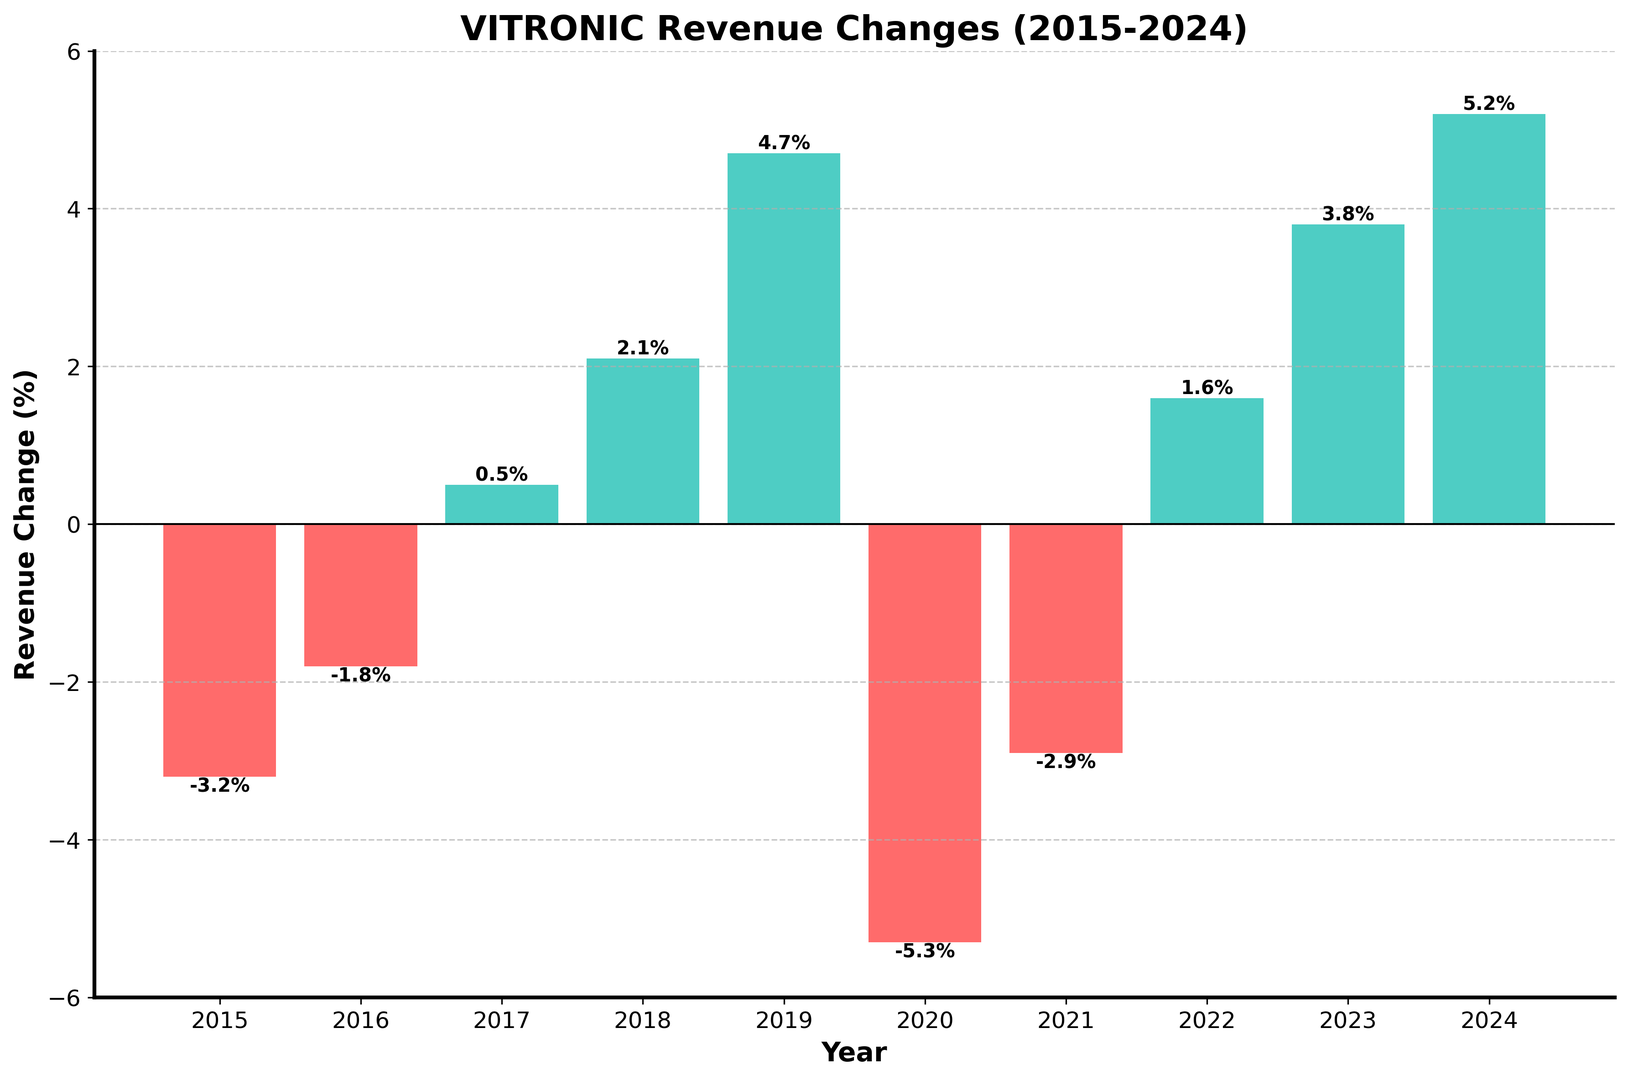How many years show a negative revenue change? By counting the number of bars that are below the zero line, we can identify how many years have negative revenue changes. The bars for the years 2015, 2016, 2020, and 2021 fall below the x-axis.
Answer: 4 Which year experienced the highest positive revenue change? By comparing the heights of the green bars above the zero line, we can identify the tallest one. The tallest green bar is in 2024.
Answer: 2024 Which year witnessed the steepest decline in revenue change? To answer this, look for the red bar that goes the farthest below the zero line. The bar for the year 2020 has the lowest value at -5.3%.
Answer: 2020 What's the average revenue change for years with positive growth? Calculate the average for the positive values: (0.5 + 2.1 + 4.7 + 1.6 + 3.8 + 5.2) / 6 = (17.9) / 6
Answer: 2.98% Between which two years does the time span contain exactly one instance of revenue decline? Against the background of counting negative and positive changes, the span from 2022 to 2024 contains exactly one instance of decline, which is from -2.9 in 2021 to 1.6 in 2022.
Answer: 2022, 2021 Which years had revenue changes below the average of all years? Calculate the average revenue change: sum all the changes and divide by the number of years. ((-3.2) + (-1.8) + 0.5 + 2.1 + 4.7 + (-5.3) + (-2.9) + 1.6 + 3.8 + 5.2) / 10 = 4.7 / 10 = 0.47%. Identify the years below this: 2015, 2016, 2020, 2021.
Answer: 2015, 2016, 2020, 2021 